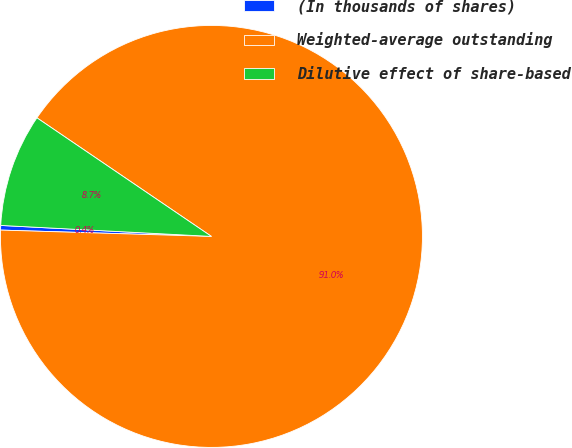Convert chart. <chart><loc_0><loc_0><loc_500><loc_500><pie_chart><fcel>(In thousands of shares)<fcel>Weighted-average outstanding<fcel>Dilutive effect of share-based<nl><fcel>0.35%<fcel>90.97%<fcel>8.67%<nl></chart> 